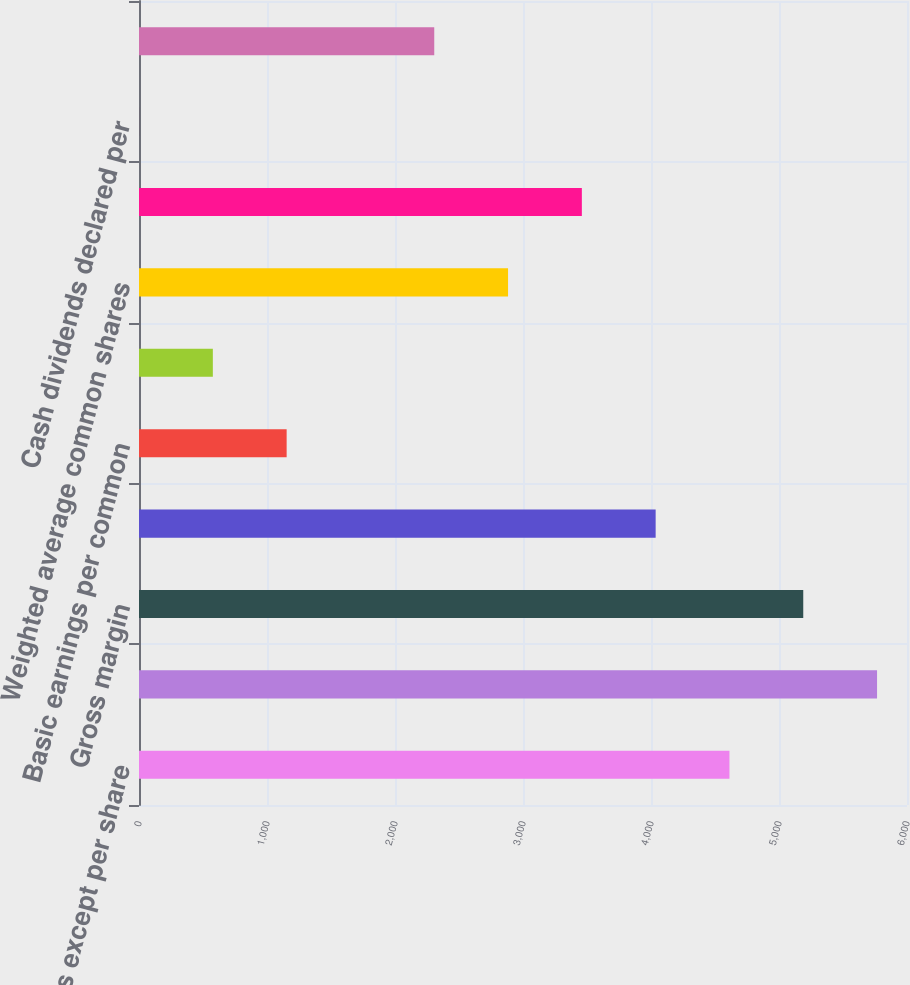Convert chart. <chart><loc_0><loc_0><loc_500><loc_500><bar_chart><fcel>(In millions except per share<fcel>Revenues<fcel>Gross margin<fcel>Net income<fcel>Basic earnings per common<fcel>Diluted earnings per common<fcel>Weighted average common shares<fcel>Diluted weighted average<fcel>Cash dividends declared per<fcel>High<nl><fcel>4612.87<fcel>5766.01<fcel>5189.44<fcel>4036.3<fcel>1153.45<fcel>576.88<fcel>2883.16<fcel>3459.73<fcel>0.31<fcel>2306.59<nl></chart> 